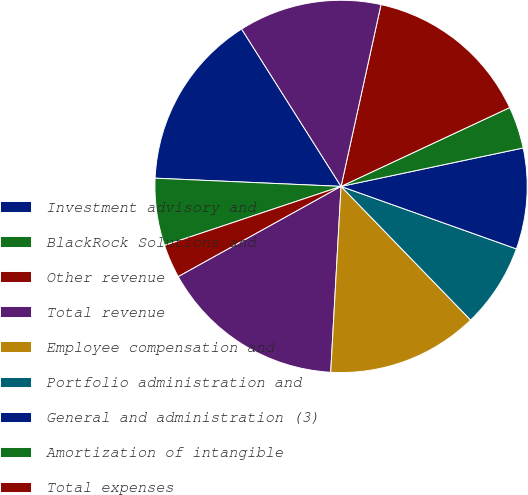Convert chart. <chart><loc_0><loc_0><loc_500><loc_500><pie_chart><fcel>Investment advisory and<fcel>BlackRock Solutions and<fcel>Other revenue<fcel>Total revenue<fcel>Employee compensation and<fcel>Portfolio administration and<fcel>General and administration (3)<fcel>Amortization of intangible<fcel>Total expenses<fcel>Operating income<nl><fcel>15.33%<fcel>5.84%<fcel>2.92%<fcel>16.06%<fcel>13.14%<fcel>7.3%<fcel>8.76%<fcel>3.65%<fcel>14.6%<fcel>12.41%<nl></chart> 